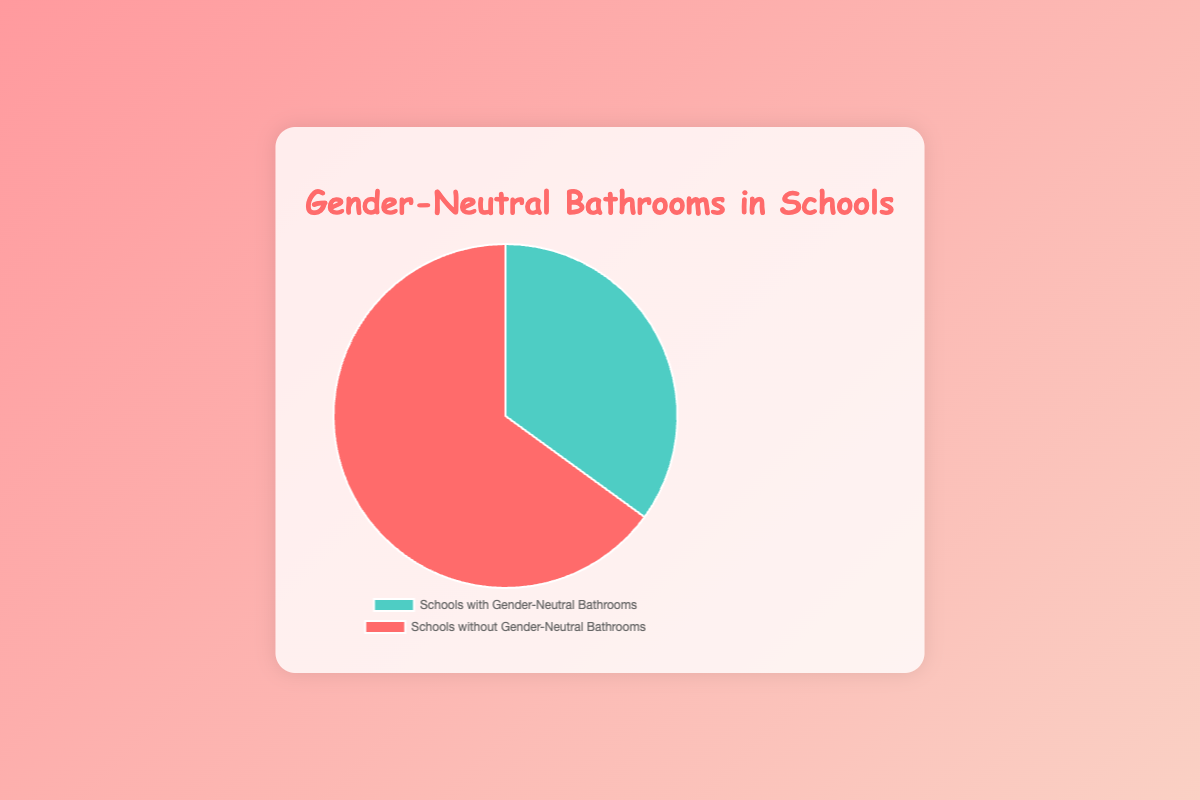What percentage of schools have gender-neutral bathrooms? The pie chart shows the proportion of schools with and without gender-neutral bathrooms. According to the chart, 35% of schools have gender-neutral bathrooms.
Answer: 35% What percentage of schools do not have gender-neutral bathrooms? Referring to the pie chart, 65% of schools do not have gender-neutral bathrooms.
Answer: 65% Is the number of schools with gender-neutral bathrooms less than or greater than the number of schools without them? Looking at the chart, the section representing schools without gender-neutral bathrooms (65%) is larger than the section representing schools with gender-neutral bathrooms (35%). Thus, the number of schools with gender-neutral bathrooms is less.
Answer: Less How much more common are schools without gender-neutral bathrooms compared to those with them? The pie chart shows that 65% of schools do not have gender-neutral bathrooms, while 35% do. The difference is 65% - 35% = 30%.
Answer: 30% What color represents schools with gender-neutral bathrooms on the chart? The chart uses color coding to differentiate between the two categories. Schools with gender-neutral bathrooms are represented by a teal color.
Answer: Teal If there are 200 schools in total, how many schools have gender-neutral bathrooms? If 35% of 200 schools have gender-neutral bathrooms, then we can calculate the number as follows: 0.35 × 200 = 70.
Answer: 70 If the percentage of schools with gender-neutral bathrooms increased by 10%, what would be the new percentage for schools with and without gender-neutral bathrooms? Currently, 35% of schools have gender-neutral bathrooms. If this increases by 10%, the new percentage is 35% + 10% = 45%. Consequently, the percentage of schools without gender-neutral bathrooms would be 100% - 45% = 55%.
Answer: 45% and 55% What visual element represents the larger group and what is its color? The larger group in the pie chart is the schools without gender-neutral bathrooms, represented by the 65% segment, which is red.
Answer: Red What is the total percentage represented in the pie chart? A pie chart represents the whole as 100%. The segments add up to 100%, with 35% for schools with gender-neutral bathrooms and 65% for those without.
Answer: 100% What change would make the chart show an equal proportion of schools with and without gender-neutral bathrooms? Currently, 35% of schools have gender-neutral bathrooms, and 65% do not. To make the proportions equal, both groups would need to be 50%. Therefore, the percentage of schools with gender-neutral bathrooms would need to increase by 15% (from 35% to 50%), and the percentage of schools without them would need to decrease by 15% (from 65% to 50%).
Answer: Both proportions would be 50% 